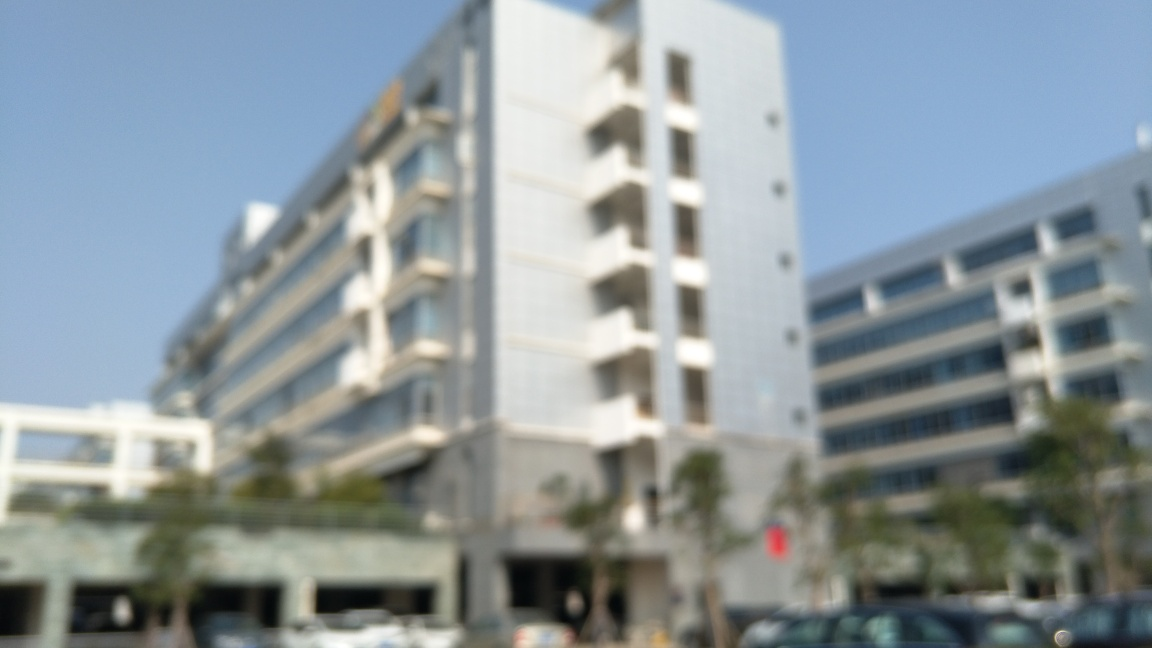Are there any quality issues with this image? Yes, the image is blurred, which affects its clarity and sharpness. This significantly reduces the quality of the image, as details of the building and surroundings cannot be discerned properly. 